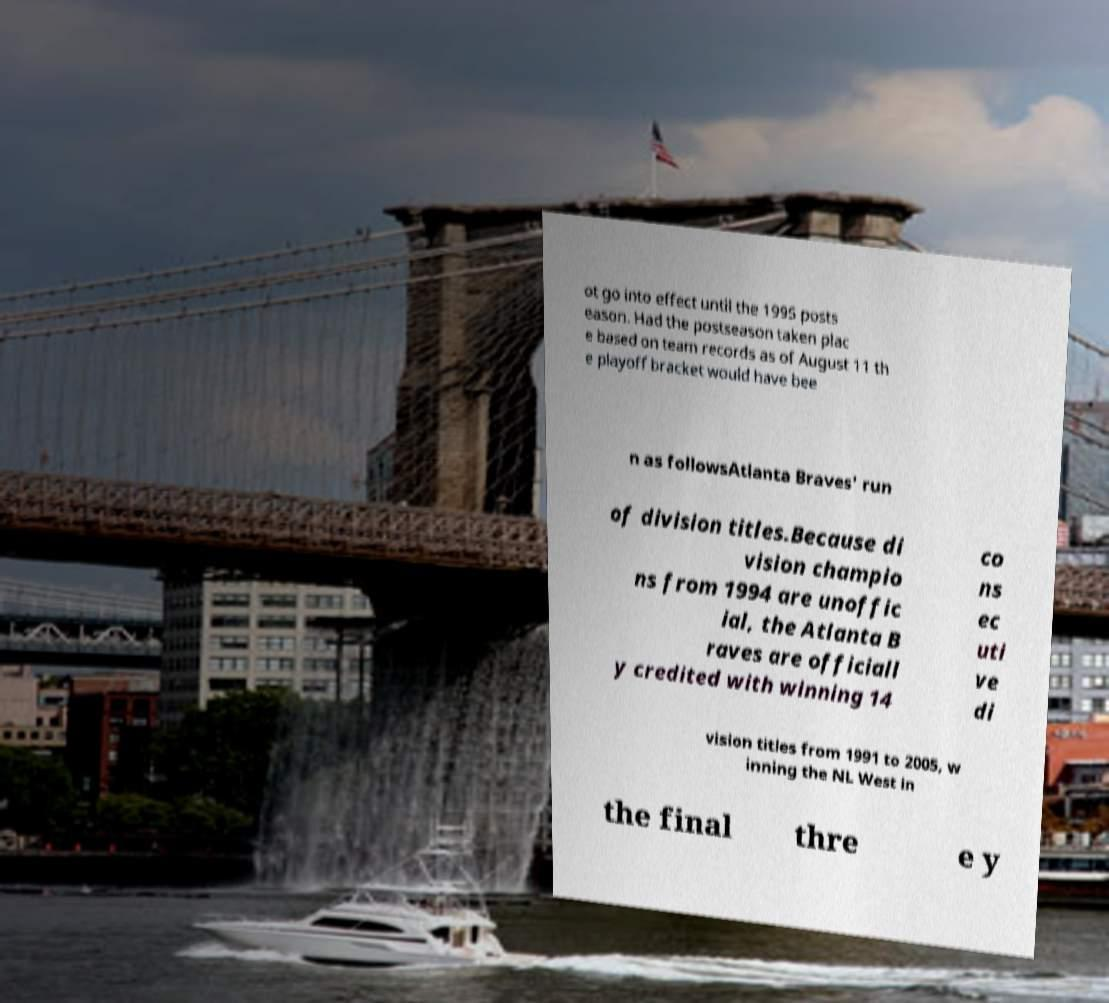Could you assist in decoding the text presented in this image and type it out clearly? ot go into effect until the 1995 posts eason. Had the postseason taken plac e based on team records as of August 11 th e playoff bracket would have bee n as followsAtlanta Braves' run of division titles.Because di vision champio ns from 1994 are unoffic ial, the Atlanta B raves are officiall y credited with winning 14 co ns ec uti ve di vision titles from 1991 to 2005, w inning the NL West in the final thre e y 